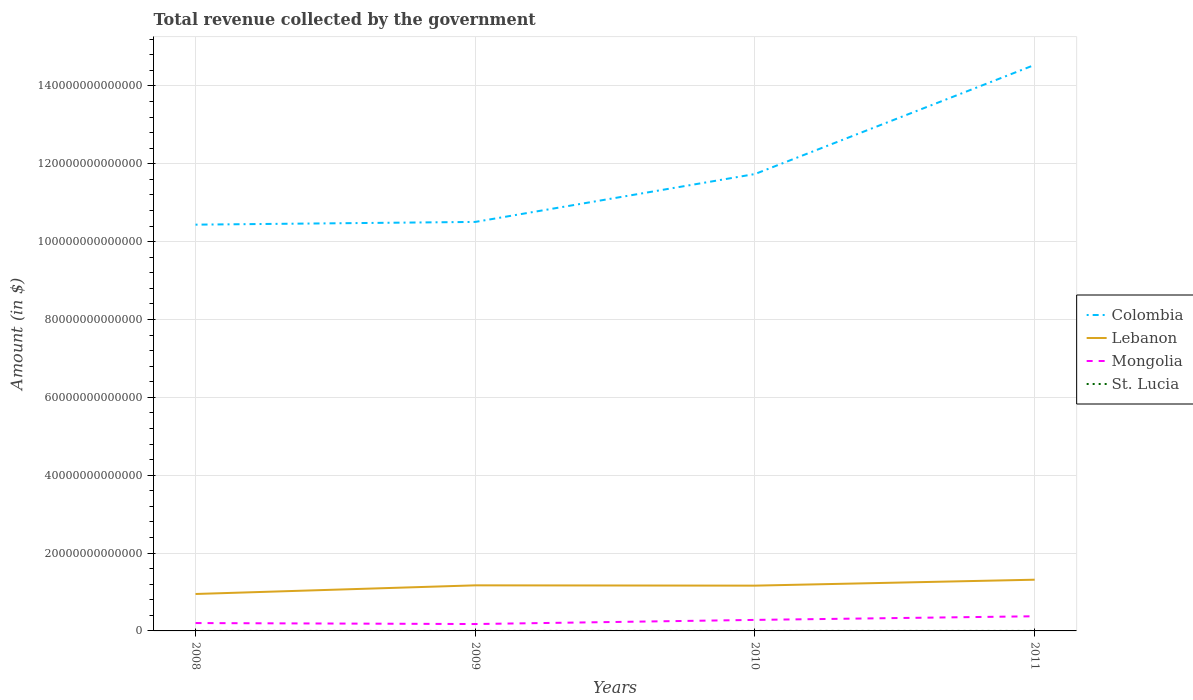How many different coloured lines are there?
Your answer should be compact. 4. Is the number of lines equal to the number of legend labels?
Ensure brevity in your answer.  Yes. Across all years, what is the maximum total revenue collected by the government in St. Lucia?
Give a very brief answer. 7.71e+08. What is the total total revenue collected by the government in St. Lucia in the graph?
Keep it short and to the point. -4.57e+07. What is the difference between the highest and the second highest total revenue collected by the government in St. Lucia?
Provide a short and direct response. 4.57e+07. How many lines are there?
Offer a very short reply. 4. What is the difference between two consecutive major ticks on the Y-axis?
Provide a short and direct response. 2.00e+13. Does the graph contain any zero values?
Your answer should be very brief. No. Does the graph contain grids?
Offer a terse response. Yes. Where does the legend appear in the graph?
Your response must be concise. Center right. What is the title of the graph?
Make the answer very short. Total revenue collected by the government. Does "American Samoa" appear as one of the legend labels in the graph?
Your answer should be compact. No. What is the label or title of the X-axis?
Offer a terse response. Years. What is the label or title of the Y-axis?
Your answer should be compact. Amount (in $). What is the Amount (in $) of Colombia in 2008?
Your answer should be very brief. 1.04e+14. What is the Amount (in $) in Lebanon in 2008?
Your response must be concise. 9.49e+12. What is the Amount (in $) of Mongolia in 2008?
Your response must be concise. 2.02e+12. What is the Amount (in $) of St. Lucia in 2008?
Provide a succinct answer. 7.81e+08. What is the Amount (in $) of Colombia in 2009?
Make the answer very short. 1.05e+14. What is the Amount (in $) of Lebanon in 2009?
Provide a short and direct response. 1.17e+13. What is the Amount (in $) of Mongolia in 2009?
Give a very brief answer. 1.77e+12. What is the Amount (in $) in St. Lucia in 2009?
Ensure brevity in your answer.  7.71e+08. What is the Amount (in $) of Colombia in 2010?
Offer a very short reply. 1.17e+14. What is the Amount (in $) of Lebanon in 2010?
Your answer should be very brief. 1.16e+13. What is the Amount (in $) of Mongolia in 2010?
Keep it short and to the point. 2.83e+12. What is the Amount (in $) in St. Lucia in 2010?
Offer a very short reply. 7.76e+08. What is the Amount (in $) of Colombia in 2011?
Provide a succinct answer. 1.45e+14. What is the Amount (in $) of Lebanon in 2011?
Your response must be concise. 1.32e+13. What is the Amount (in $) in Mongolia in 2011?
Offer a very short reply. 3.77e+12. What is the Amount (in $) of St. Lucia in 2011?
Make the answer very short. 8.17e+08. Across all years, what is the maximum Amount (in $) of Colombia?
Offer a terse response. 1.45e+14. Across all years, what is the maximum Amount (in $) of Lebanon?
Your answer should be compact. 1.32e+13. Across all years, what is the maximum Amount (in $) in Mongolia?
Make the answer very short. 3.77e+12. Across all years, what is the maximum Amount (in $) in St. Lucia?
Make the answer very short. 8.17e+08. Across all years, what is the minimum Amount (in $) in Colombia?
Make the answer very short. 1.04e+14. Across all years, what is the minimum Amount (in $) of Lebanon?
Your answer should be very brief. 9.49e+12. Across all years, what is the minimum Amount (in $) in Mongolia?
Offer a terse response. 1.77e+12. Across all years, what is the minimum Amount (in $) in St. Lucia?
Make the answer very short. 7.71e+08. What is the total Amount (in $) in Colombia in the graph?
Offer a terse response. 4.72e+14. What is the total Amount (in $) in Lebanon in the graph?
Provide a succinct answer. 4.60e+13. What is the total Amount (in $) of Mongolia in the graph?
Make the answer very short. 1.04e+13. What is the total Amount (in $) of St. Lucia in the graph?
Your answer should be very brief. 3.14e+09. What is the difference between the Amount (in $) of Colombia in 2008 and that in 2009?
Make the answer very short. -7.04e+11. What is the difference between the Amount (in $) in Lebanon in 2008 and that in 2009?
Keep it short and to the point. -2.22e+12. What is the difference between the Amount (in $) of Mongolia in 2008 and that in 2009?
Ensure brevity in your answer.  2.52e+11. What is the difference between the Amount (in $) in St. Lucia in 2008 and that in 2009?
Your response must be concise. 1.03e+07. What is the difference between the Amount (in $) of Colombia in 2008 and that in 2010?
Provide a succinct answer. -1.30e+13. What is the difference between the Amount (in $) in Lebanon in 2008 and that in 2010?
Your answer should be compact. -2.14e+12. What is the difference between the Amount (in $) in Mongolia in 2008 and that in 2010?
Your answer should be very brief. -8.12e+11. What is the difference between the Amount (in $) of St. Lucia in 2008 and that in 2010?
Offer a very short reply. 4.90e+06. What is the difference between the Amount (in $) of Colombia in 2008 and that in 2011?
Your answer should be compact. -4.10e+13. What is the difference between the Amount (in $) in Lebanon in 2008 and that in 2011?
Your answer should be very brief. -3.67e+12. What is the difference between the Amount (in $) of Mongolia in 2008 and that in 2011?
Ensure brevity in your answer.  -1.75e+12. What is the difference between the Amount (in $) of St. Lucia in 2008 and that in 2011?
Provide a succinct answer. -3.54e+07. What is the difference between the Amount (in $) in Colombia in 2009 and that in 2010?
Offer a very short reply. -1.23e+13. What is the difference between the Amount (in $) of Lebanon in 2009 and that in 2010?
Provide a succinct answer. 7.68e+1. What is the difference between the Amount (in $) of Mongolia in 2009 and that in 2010?
Ensure brevity in your answer.  -1.06e+12. What is the difference between the Amount (in $) in St. Lucia in 2009 and that in 2010?
Your answer should be compact. -5.40e+06. What is the difference between the Amount (in $) in Colombia in 2009 and that in 2011?
Offer a very short reply. -4.03e+13. What is the difference between the Amount (in $) in Lebanon in 2009 and that in 2011?
Your answer should be very brief. -1.45e+12. What is the difference between the Amount (in $) in Mongolia in 2009 and that in 2011?
Your answer should be very brief. -2.00e+12. What is the difference between the Amount (in $) in St. Lucia in 2009 and that in 2011?
Offer a very short reply. -4.57e+07. What is the difference between the Amount (in $) of Colombia in 2010 and that in 2011?
Your answer should be compact. -2.80e+13. What is the difference between the Amount (in $) of Lebanon in 2010 and that in 2011?
Provide a short and direct response. -1.52e+12. What is the difference between the Amount (in $) of Mongolia in 2010 and that in 2011?
Ensure brevity in your answer.  -9.35e+11. What is the difference between the Amount (in $) of St. Lucia in 2010 and that in 2011?
Offer a terse response. -4.03e+07. What is the difference between the Amount (in $) in Colombia in 2008 and the Amount (in $) in Lebanon in 2009?
Provide a short and direct response. 9.27e+13. What is the difference between the Amount (in $) in Colombia in 2008 and the Amount (in $) in Mongolia in 2009?
Make the answer very short. 1.03e+14. What is the difference between the Amount (in $) of Colombia in 2008 and the Amount (in $) of St. Lucia in 2009?
Provide a succinct answer. 1.04e+14. What is the difference between the Amount (in $) in Lebanon in 2008 and the Amount (in $) in Mongolia in 2009?
Your response must be concise. 7.72e+12. What is the difference between the Amount (in $) of Lebanon in 2008 and the Amount (in $) of St. Lucia in 2009?
Offer a terse response. 9.49e+12. What is the difference between the Amount (in $) of Mongolia in 2008 and the Amount (in $) of St. Lucia in 2009?
Your response must be concise. 2.02e+12. What is the difference between the Amount (in $) in Colombia in 2008 and the Amount (in $) in Lebanon in 2010?
Keep it short and to the point. 9.27e+13. What is the difference between the Amount (in $) of Colombia in 2008 and the Amount (in $) of Mongolia in 2010?
Offer a very short reply. 1.02e+14. What is the difference between the Amount (in $) in Colombia in 2008 and the Amount (in $) in St. Lucia in 2010?
Provide a short and direct response. 1.04e+14. What is the difference between the Amount (in $) in Lebanon in 2008 and the Amount (in $) in Mongolia in 2010?
Keep it short and to the point. 6.66e+12. What is the difference between the Amount (in $) of Lebanon in 2008 and the Amount (in $) of St. Lucia in 2010?
Ensure brevity in your answer.  9.49e+12. What is the difference between the Amount (in $) of Mongolia in 2008 and the Amount (in $) of St. Lucia in 2010?
Offer a terse response. 2.02e+12. What is the difference between the Amount (in $) in Colombia in 2008 and the Amount (in $) in Lebanon in 2011?
Give a very brief answer. 9.12e+13. What is the difference between the Amount (in $) of Colombia in 2008 and the Amount (in $) of Mongolia in 2011?
Your answer should be compact. 1.01e+14. What is the difference between the Amount (in $) of Colombia in 2008 and the Amount (in $) of St. Lucia in 2011?
Give a very brief answer. 1.04e+14. What is the difference between the Amount (in $) of Lebanon in 2008 and the Amount (in $) of Mongolia in 2011?
Your answer should be compact. 5.72e+12. What is the difference between the Amount (in $) in Lebanon in 2008 and the Amount (in $) in St. Lucia in 2011?
Ensure brevity in your answer.  9.49e+12. What is the difference between the Amount (in $) in Mongolia in 2008 and the Amount (in $) in St. Lucia in 2011?
Your response must be concise. 2.02e+12. What is the difference between the Amount (in $) in Colombia in 2009 and the Amount (in $) in Lebanon in 2010?
Offer a very short reply. 9.34e+13. What is the difference between the Amount (in $) in Colombia in 2009 and the Amount (in $) in Mongolia in 2010?
Make the answer very short. 1.02e+14. What is the difference between the Amount (in $) in Colombia in 2009 and the Amount (in $) in St. Lucia in 2010?
Make the answer very short. 1.05e+14. What is the difference between the Amount (in $) in Lebanon in 2009 and the Amount (in $) in Mongolia in 2010?
Your answer should be compact. 8.88e+12. What is the difference between the Amount (in $) of Lebanon in 2009 and the Amount (in $) of St. Lucia in 2010?
Offer a terse response. 1.17e+13. What is the difference between the Amount (in $) in Mongolia in 2009 and the Amount (in $) in St. Lucia in 2010?
Give a very brief answer. 1.77e+12. What is the difference between the Amount (in $) in Colombia in 2009 and the Amount (in $) in Lebanon in 2011?
Keep it short and to the point. 9.19e+13. What is the difference between the Amount (in $) of Colombia in 2009 and the Amount (in $) of Mongolia in 2011?
Ensure brevity in your answer.  1.01e+14. What is the difference between the Amount (in $) of Colombia in 2009 and the Amount (in $) of St. Lucia in 2011?
Offer a very short reply. 1.05e+14. What is the difference between the Amount (in $) in Lebanon in 2009 and the Amount (in $) in Mongolia in 2011?
Your answer should be compact. 7.94e+12. What is the difference between the Amount (in $) of Lebanon in 2009 and the Amount (in $) of St. Lucia in 2011?
Offer a very short reply. 1.17e+13. What is the difference between the Amount (in $) of Mongolia in 2009 and the Amount (in $) of St. Lucia in 2011?
Ensure brevity in your answer.  1.77e+12. What is the difference between the Amount (in $) of Colombia in 2010 and the Amount (in $) of Lebanon in 2011?
Offer a very short reply. 1.04e+14. What is the difference between the Amount (in $) of Colombia in 2010 and the Amount (in $) of Mongolia in 2011?
Provide a succinct answer. 1.14e+14. What is the difference between the Amount (in $) of Colombia in 2010 and the Amount (in $) of St. Lucia in 2011?
Your answer should be compact. 1.17e+14. What is the difference between the Amount (in $) of Lebanon in 2010 and the Amount (in $) of Mongolia in 2011?
Your answer should be very brief. 7.87e+12. What is the difference between the Amount (in $) in Lebanon in 2010 and the Amount (in $) in St. Lucia in 2011?
Offer a terse response. 1.16e+13. What is the difference between the Amount (in $) in Mongolia in 2010 and the Amount (in $) in St. Lucia in 2011?
Provide a short and direct response. 2.83e+12. What is the average Amount (in $) of Colombia per year?
Offer a very short reply. 1.18e+14. What is the average Amount (in $) of Lebanon per year?
Your response must be concise. 1.15e+13. What is the average Amount (in $) in Mongolia per year?
Your answer should be compact. 2.60e+12. What is the average Amount (in $) of St. Lucia per year?
Make the answer very short. 7.86e+08. In the year 2008, what is the difference between the Amount (in $) in Colombia and Amount (in $) in Lebanon?
Make the answer very short. 9.49e+13. In the year 2008, what is the difference between the Amount (in $) in Colombia and Amount (in $) in Mongolia?
Your response must be concise. 1.02e+14. In the year 2008, what is the difference between the Amount (in $) of Colombia and Amount (in $) of St. Lucia?
Offer a terse response. 1.04e+14. In the year 2008, what is the difference between the Amount (in $) in Lebanon and Amount (in $) in Mongolia?
Your response must be concise. 7.47e+12. In the year 2008, what is the difference between the Amount (in $) in Lebanon and Amount (in $) in St. Lucia?
Keep it short and to the point. 9.49e+12. In the year 2008, what is the difference between the Amount (in $) of Mongolia and Amount (in $) of St. Lucia?
Your answer should be compact. 2.02e+12. In the year 2009, what is the difference between the Amount (in $) of Colombia and Amount (in $) of Lebanon?
Provide a succinct answer. 9.34e+13. In the year 2009, what is the difference between the Amount (in $) in Colombia and Amount (in $) in Mongolia?
Offer a terse response. 1.03e+14. In the year 2009, what is the difference between the Amount (in $) in Colombia and Amount (in $) in St. Lucia?
Your answer should be very brief. 1.05e+14. In the year 2009, what is the difference between the Amount (in $) in Lebanon and Amount (in $) in Mongolia?
Provide a succinct answer. 9.94e+12. In the year 2009, what is the difference between the Amount (in $) in Lebanon and Amount (in $) in St. Lucia?
Make the answer very short. 1.17e+13. In the year 2009, what is the difference between the Amount (in $) of Mongolia and Amount (in $) of St. Lucia?
Your answer should be very brief. 1.77e+12. In the year 2010, what is the difference between the Amount (in $) in Colombia and Amount (in $) in Lebanon?
Keep it short and to the point. 1.06e+14. In the year 2010, what is the difference between the Amount (in $) in Colombia and Amount (in $) in Mongolia?
Your response must be concise. 1.15e+14. In the year 2010, what is the difference between the Amount (in $) in Colombia and Amount (in $) in St. Lucia?
Keep it short and to the point. 1.17e+14. In the year 2010, what is the difference between the Amount (in $) of Lebanon and Amount (in $) of Mongolia?
Provide a succinct answer. 8.80e+12. In the year 2010, what is the difference between the Amount (in $) in Lebanon and Amount (in $) in St. Lucia?
Ensure brevity in your answer.  1.16e+13. In the year 2010, what is the difference between the Amount (in $) in Mongolia and Amount (in $) in St. Lucia?
Provide a succinct answer. 2.83e+12. In the year 2011, what is the difference between the Amount (in $) of Colombia and Amount (in $) of Lebanon?
Offer a terse response. 1.32e+14. In the year 2011, what is the difference between the Amount (in $) of Colombia and Amount (in $) of Mongolia?
Keep it short and to the point. 1.42e+14. In the year 2011, what is the difference between the Amount (in $) of Colombia and Amount (in $) of St. Lucia?
Ensure brevity in your answer.  1.45e+14. In the year 2011, what is the difference between the Amount (in $) in Lebanon and Amount (in $) in Mongolia?
Ensure brevity in your answer.  9.39e+12. In the year 2011, what is the difference between the Amount (in $) in Lebanon and Amount (in $) in St. Lucia?
Give a very brief answer. 1.32e+13. In the year 2011, what is the difference between the Amount (in $) in Mongolia and Amount (in $) in St. Lucia?
Offer a very short reply. 3.77e+12. What is the ratio of the Amount (in $) of Lebanon in 2008 to that in 2009?
Offer a very short reply. 0.81. What is the ratio of the Amount (in $) in Mongolia in 2008 to that in 2009?
Give a very brief answer. 1.14. What is the ratio of the Amount (in $) in St. Lucia in 2008 to that in 2009?
Your answer should be compact. 1.01. What is the ratio of the Amount (in $) of Colombia in 2008 to that in 2010?
Offer a very short reply. 0.89. What is the ratio of the Amount (in $) in Lebanon in 2008 to that in 2010?
Provide a succinct answer. 0.82. What is the ratio of the Amount (in $) of Mongolia in 2008 to that in 2010?
Provide a short and direct response. 0.71. What is the ratio of the Amount (in $) in Colombia in 2008 to that in 2011?
Your answer should be compact. 0.72. What is the ratio of the Amount (in $) of Lebanon in 2008 to that in 2011?
Your answer should be compact. 0.72. What is the ratio of the Amount (in $) of Mongolia in 2008 to that in 2011?
Offer a terse response. 0.54. What is the ratio of the Amount (in $) in St. Lucia in 2008 to that in 2011?
Keep it short and to the point. 0.96. What is the ratio of the Amount (in $) of Colombia in 2009 to that in 2010?
Keep it short and to the point. 0.9. What is the ratio of the Amount (in $) in Lebanon in 2009 to that in 2010?
Your answer should be very brief. 1.01. What is the ratio of the Amount (in $) of Mongolia in 2009 to that in 2010?
Make the answer very short. 0.62. What is the ratio of the Amount (in $) of St. Lucia in 2009 to that in 2010?
Your response must be concise. 0.99. What is the ratio of the Amount (in $) of Colombia in 2009 to that in 2011?
Make the answer very short. 0.72. What is the ratio of the Amount (in $) in Lebanon in 2009 to that in 2011?
Your response must be concise. 0.89. What is the ratio of the Amount (in $) in Mongolia in 2009 to that in 2011?
Keep it short and to the point. 0.47. What is the ratio of the Amount (in $) in St. Lucia in 2009 to that in 2011?
Give a very brief answer. 0.94. What is the ratio of the Amount (in $) in Colombia in 2010 to that in 2011?
Give a very brief answer. 0.81. What is the ratio of the Amount (in $) of Lebanon in 2010 to that in 2011?
Ensure brevity in your answer.  0.88. What is the ratio of the Amount (in $) in Mongolia in 2010 to that in 2011?
Keep it short and to the point. 0.75. What is the ratio of the Amount (in $) of St. Lucia in 2010 to that in 2011?
Your answer should be compact. 0.95. What is the difference between the highest and the second highest Amount (in $) in Colombia?
Your answer should be very brief. 2.80e+13. What is the difference between the highest and the second highest Amount (in $) in Lebanon?
Offer a terse response. 1.45e+12. What is the difference between the highest and the second highest Amount (in $) of Mongolia?
Provide a succinct answer. 9.35e+11. What is the difference between the highest and the second highest Amount (in $) in St. Lucia?
Ensure brevity in your answer.  3.54e+07. What is the difference between the highest and the lowest Amount (in $) in Colombia?
Your answer should be compact. 4.10e+13. What is the difference between the highest and the lowest Amount (in $) in Lebanon?
Keep it short and to the point. 3.67e+12. What is the difference between the highest and the lowest Amount (in $) of Mongolia?
Provide a short and direct response. 2.00e+12. What is the difference between the highest and the lowest Amount (in $) of St. Lucia?
Ensure brevity in your answer.  4.57e+07. 